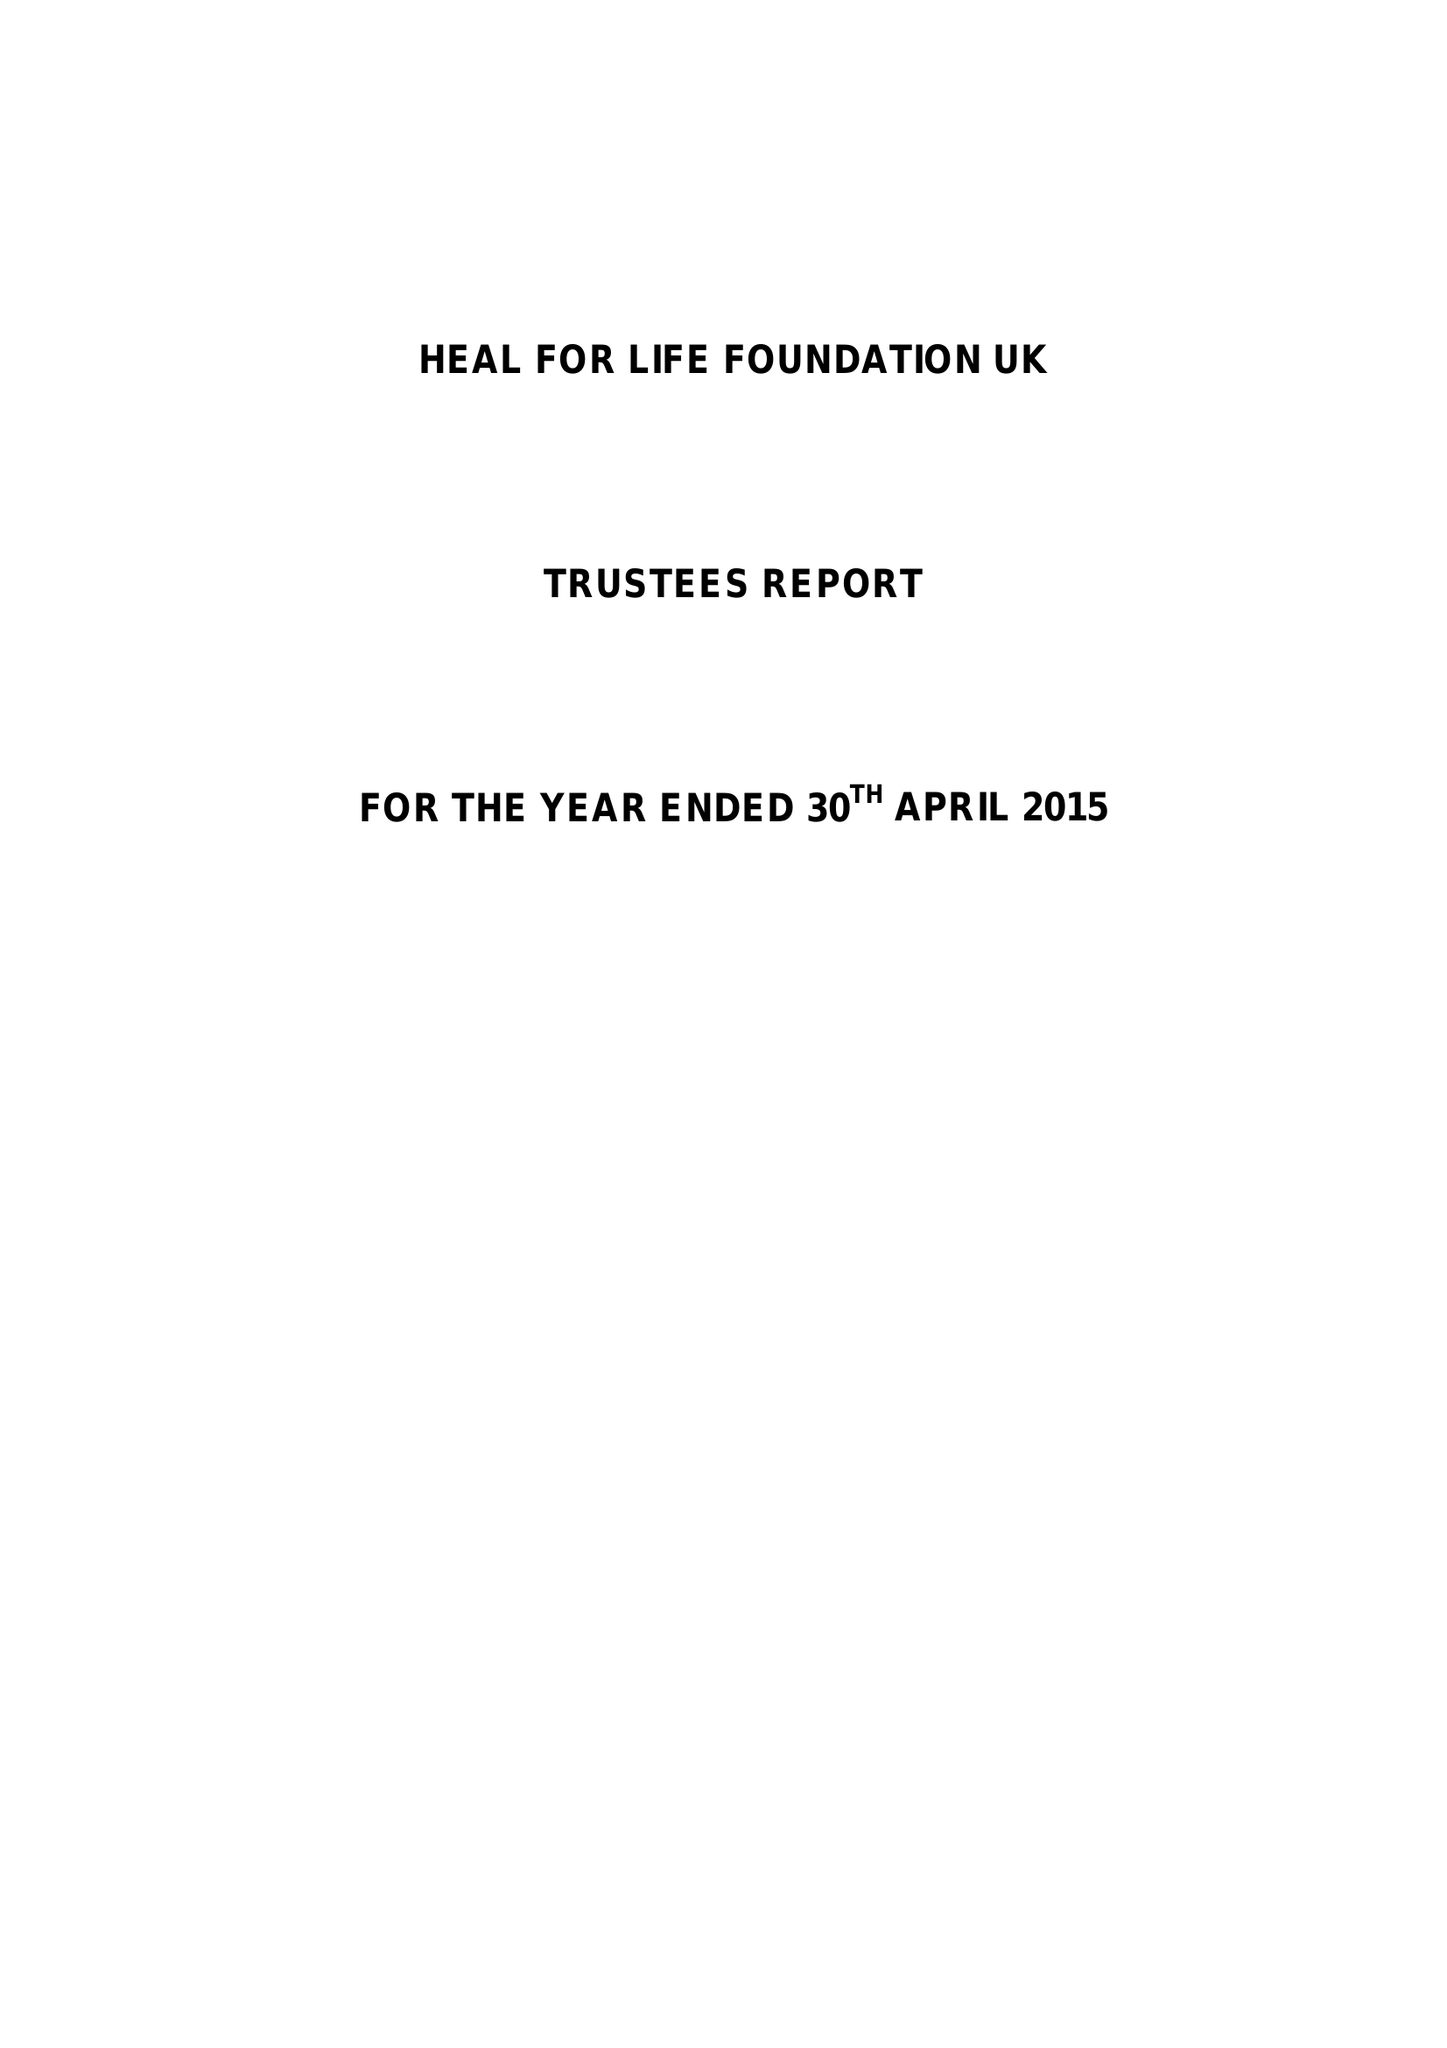What is the value for the charity_number?
Answer the question using a single word or phrase. 1156694 